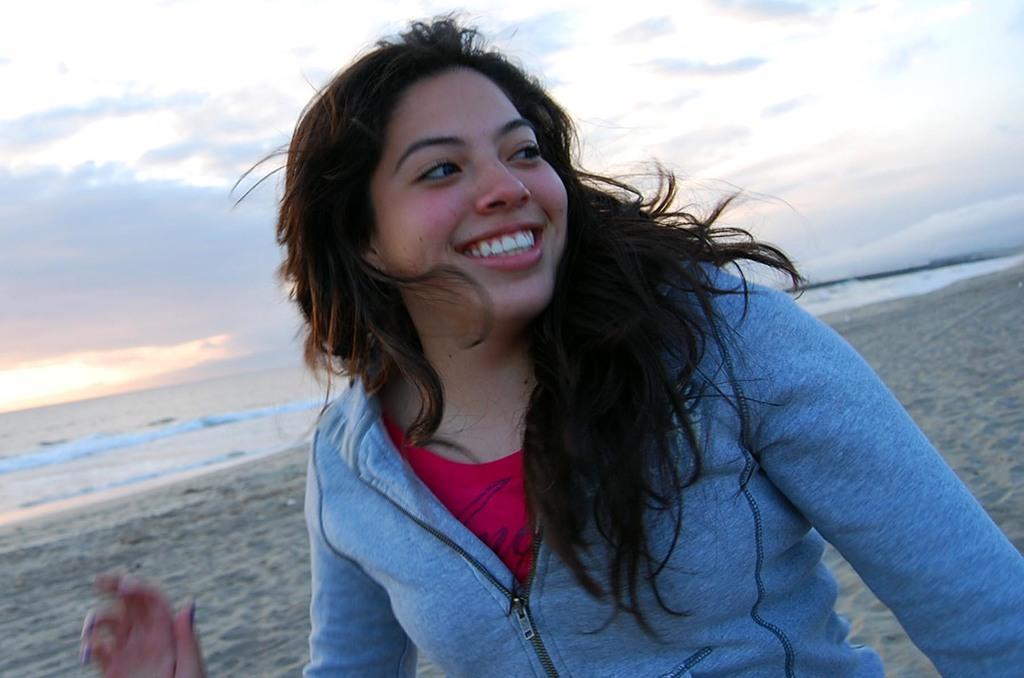Could you give a brief overview of what you see in this image? In this picture we can see a woman smiling. There is sand. Waves are visible in the water. Sky is cloudy. 